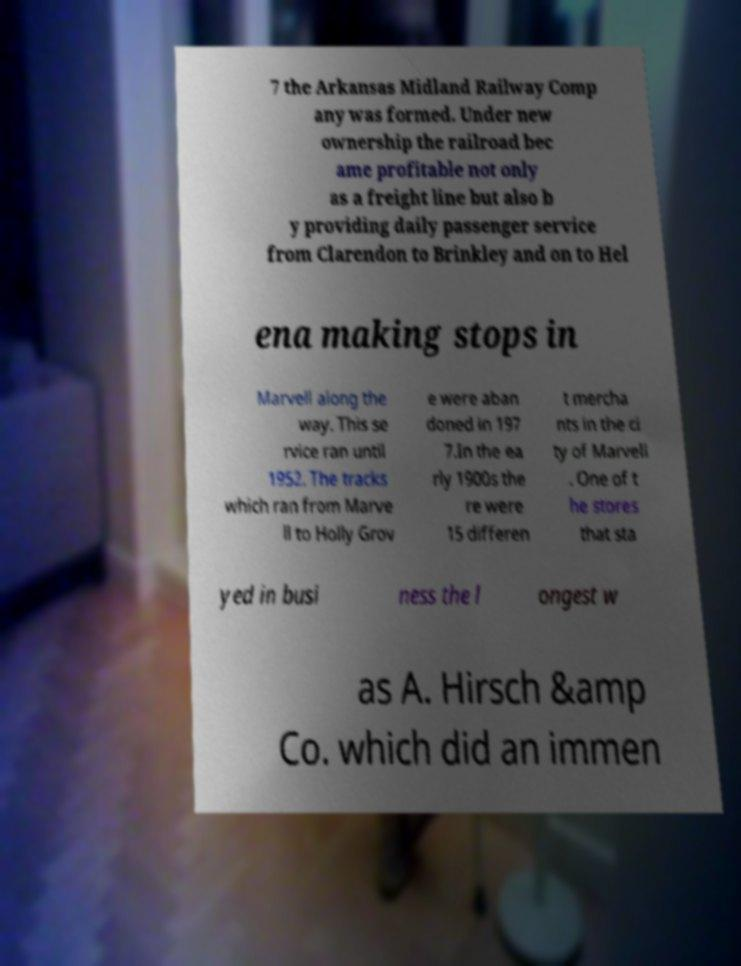Can you read and provide the text displayed in the image?This photo seems to have some interesting text. Can you extract and type it out for me? 7 the Arkansas Midland Railway Comp any was formed. Under new ownership the railroad bec ame profitable not only as a freight line but also b y providing daily passenger service from Clarendon to Brinkley and on to Hel ena making stops in Marvell along the way. This se rvice ran until 1952. The tracks which ran from Marve ll to Holly Grov e were aban doned in 197 7.In the ea rly 1900s the re were 15 differen t mercha nts in the ci ty of Marvell . One of t he stores that sta yed in busi ness the l ongest w as A. Hirsch &amp Co. which did an immen 